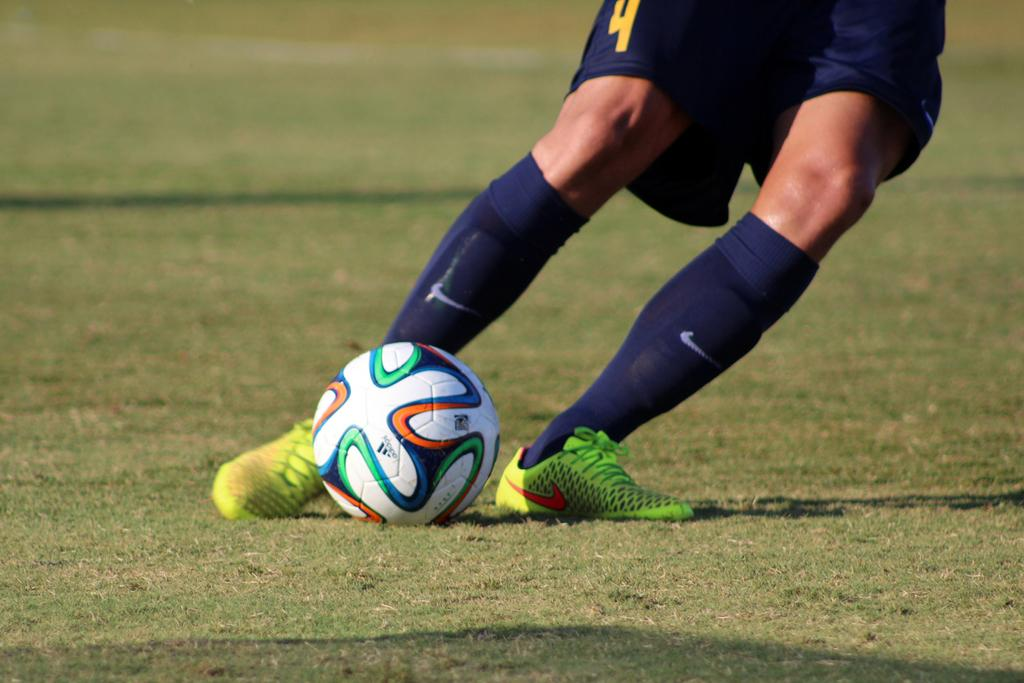<image>
Create a compact narrative representing the image presented. Player number 4 kicks the soccer ball while wearing Nike socks. 